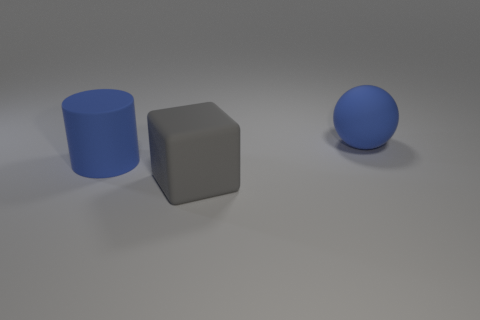How many blue rubber objects are the same size as the gray matte thing? There are two blue rubber objects in the image, and both appear to be of similar size to the single gray matte object depicted. 